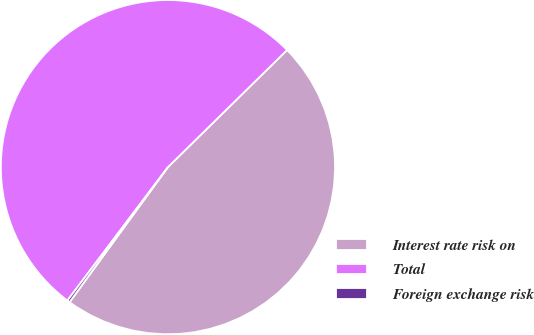Convert chart to OTSL. <chart><loc_0><loc_0><loc_500><loc_500><pie_chart><fcel>Interest rate risk on<fcel>Total<fcel>Foreign exchange risk<nl><fcel>47.38%<fcel>52.36%<fcel>0.26%<nl></chart> 